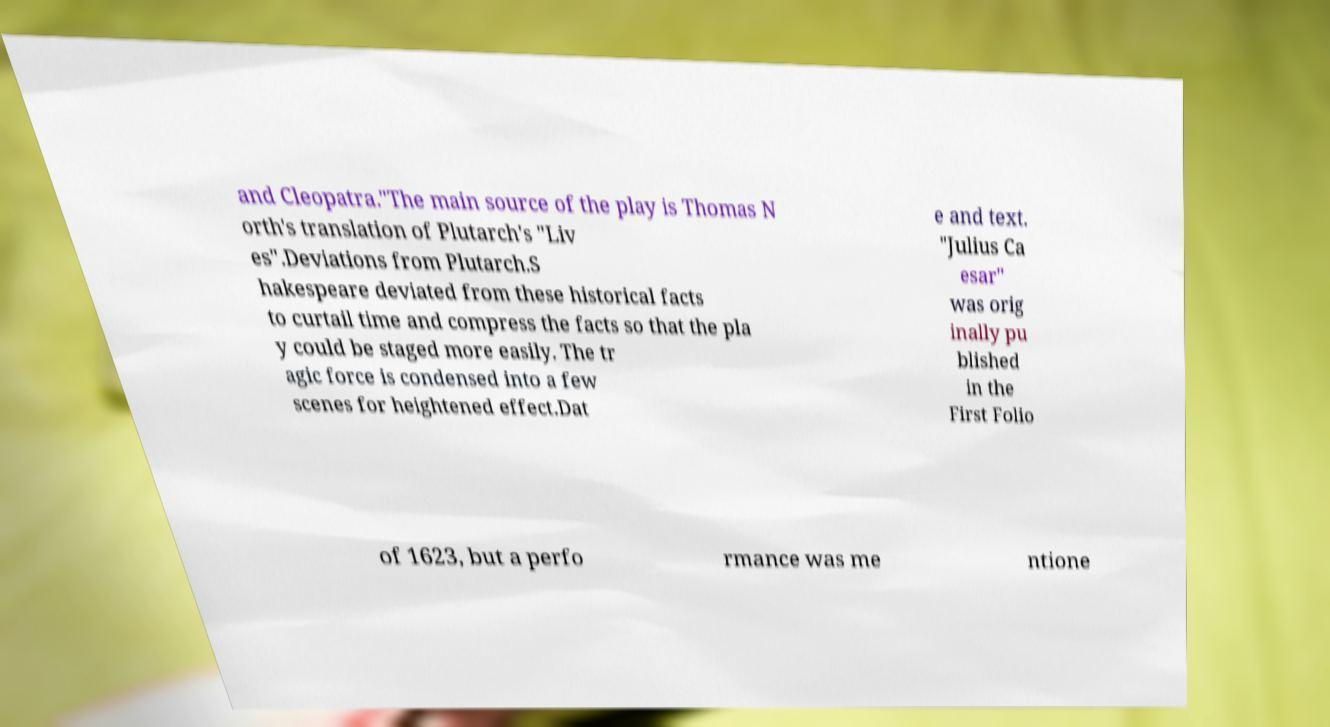Could you extract and type out the text from this image? and Cleopatra."The main source of the play is Thomas N orth's translation of Plutarch's "Liv es".Deviations from Plutarch.S hakespeare deviated from these historical facts to curtail time and compress the facts so that the pla y could be staged more easily. The tr agic force is condensed into a few scenes for heightened effect.Dat e and text. "Julius Ca esar" was orig inally pu blished in the First Folio of 1623, but a perfo rmance was me ntione 